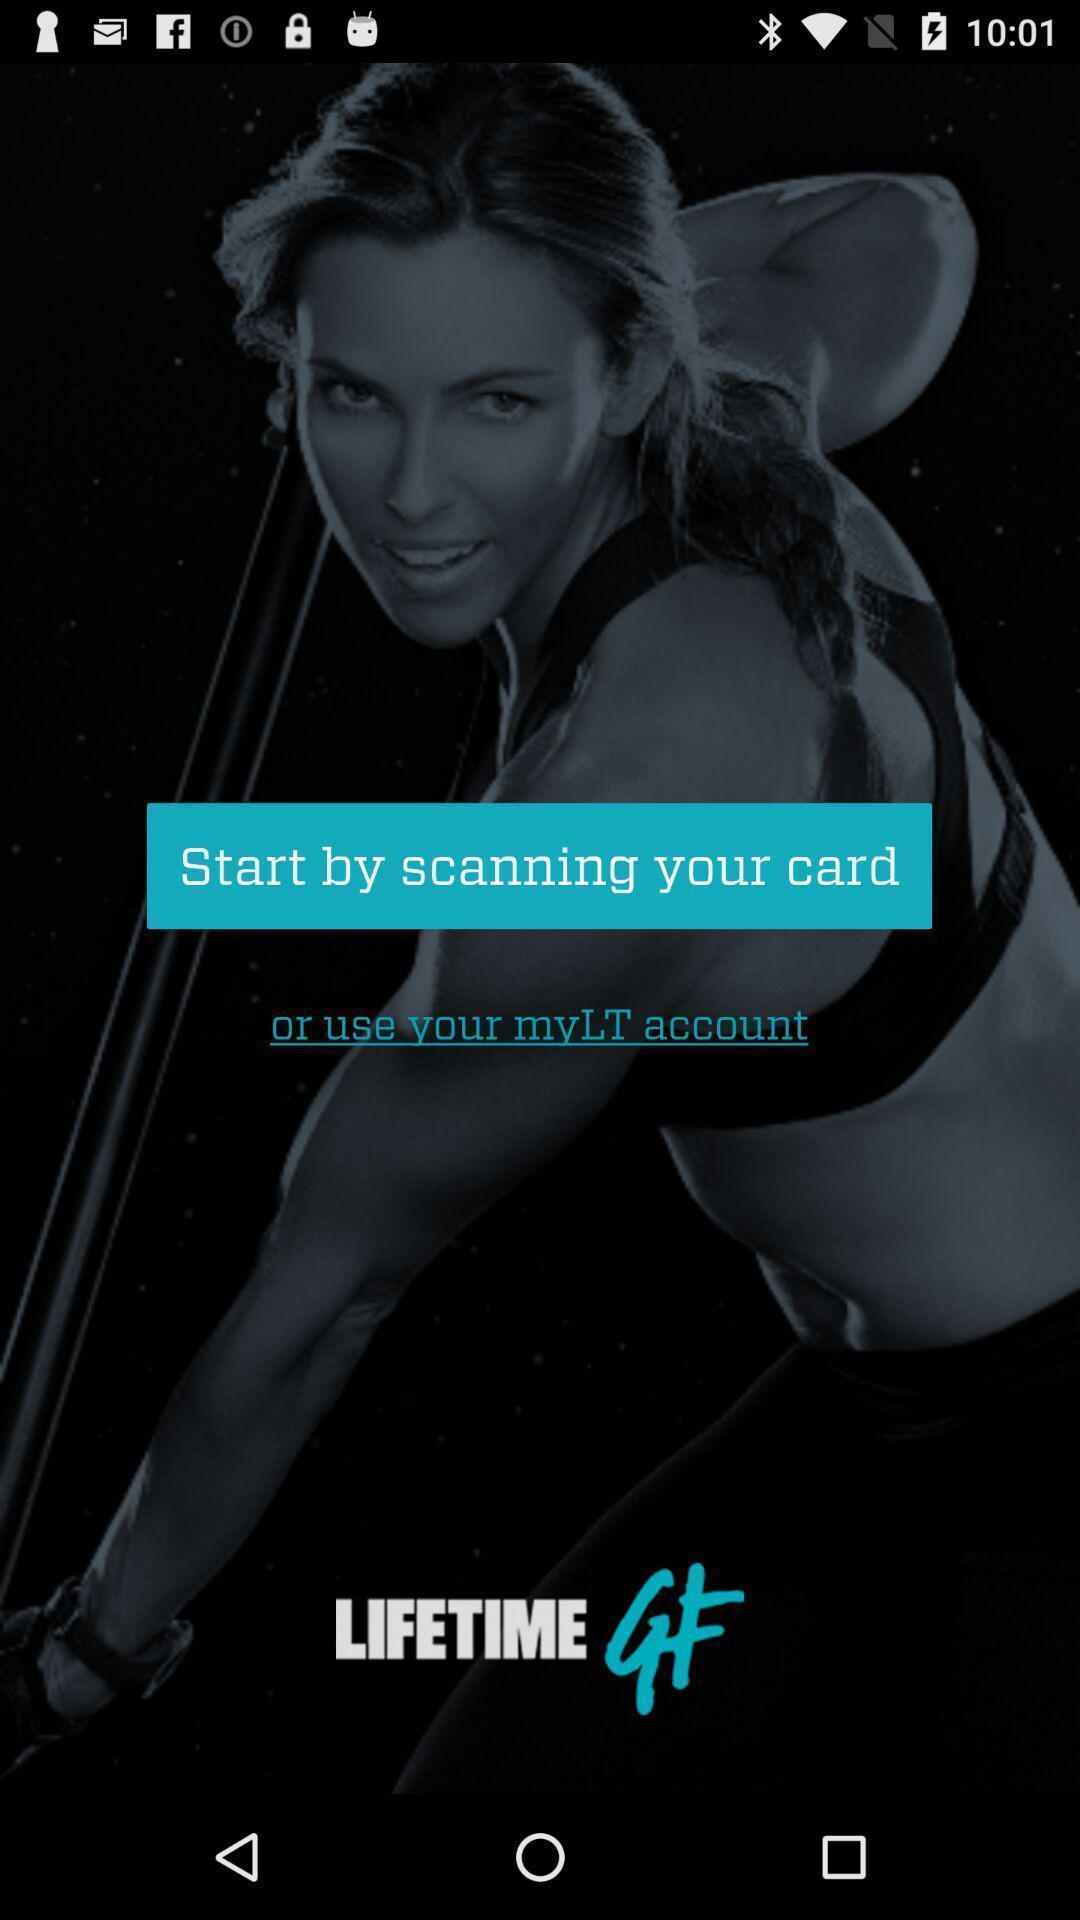Describe the content in this image. Welcome screen. 